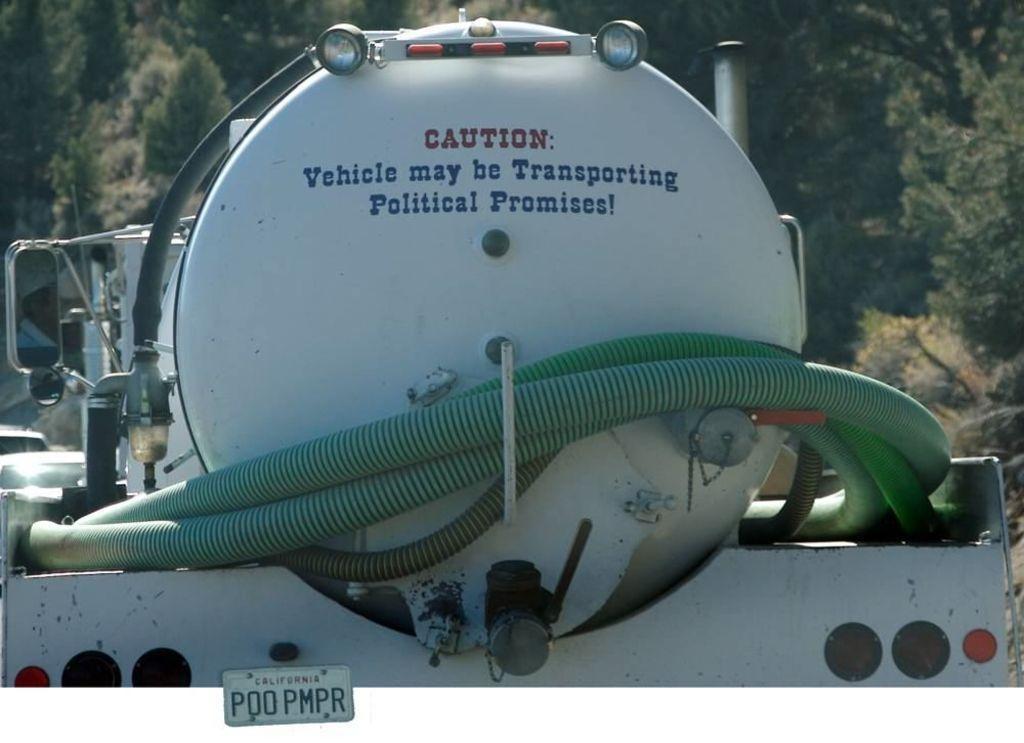Can you describe this image briefly? In this picture we can see a vehicle with pipes, number plate, mirrors and some objects on it and in the background we can see trees. 